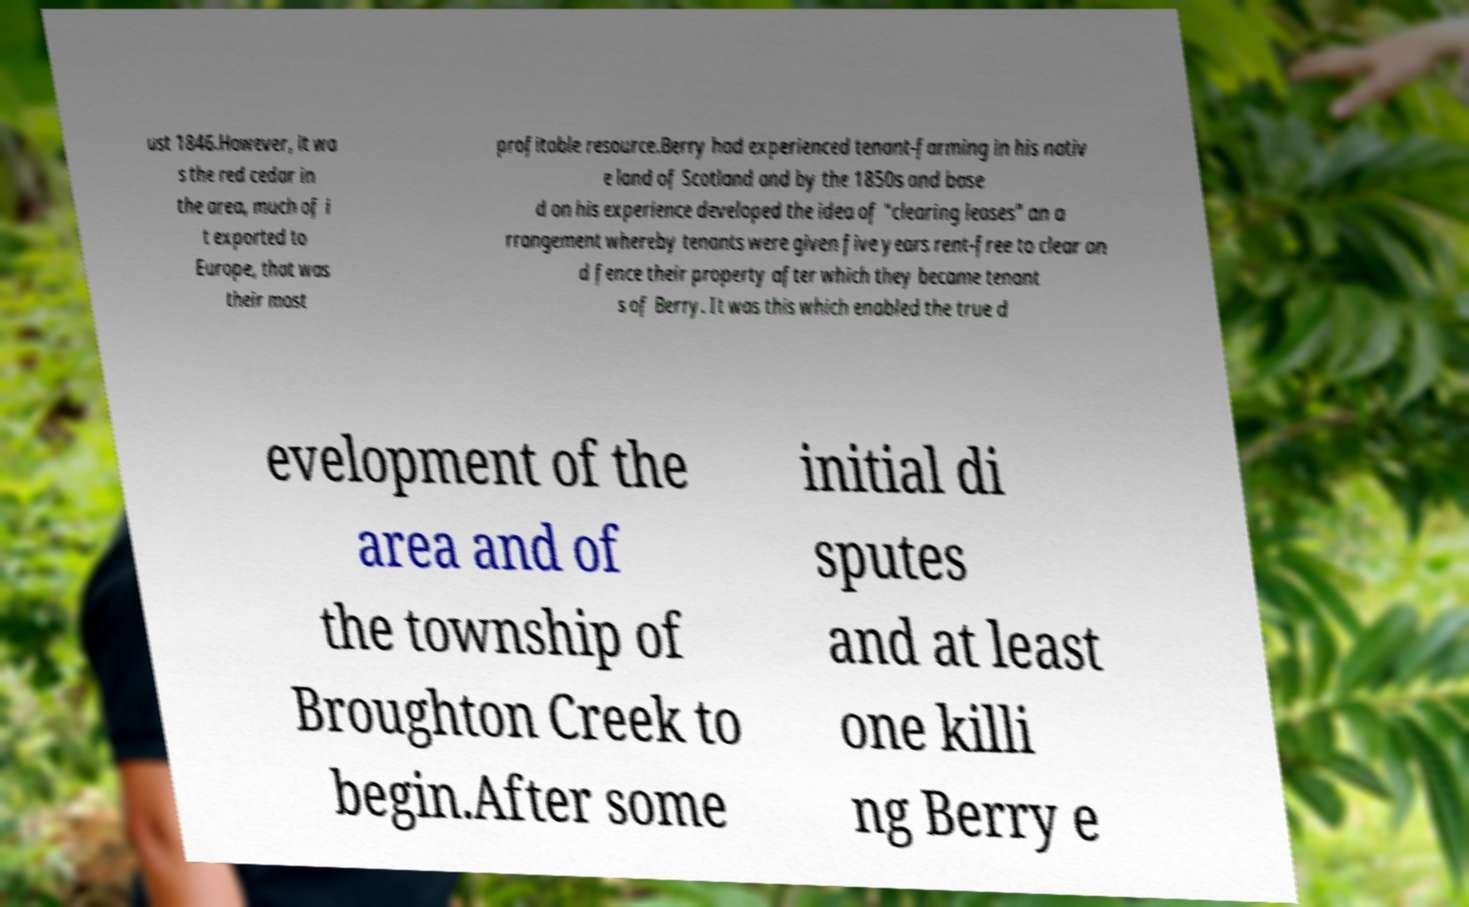What messages or text are displayed in this image? I need them in a readable, typed format. ust 1846.However, it wa s the red cedar in the area, much of i t exported to Europe, that was their most profitable resource.Berry had experienced tenant-farming in his nativ e land of Scotland and by the 1850s and base d on his experience developed the idea of "clearing leases" an a rrangement whereby tenants were given five years rent-free to clear an d fence their property after which they became tenant s of Berry. It was this which enabled the true d evelopment of the area and of the township of Broughton Creek to begin.After some initial di sputes and at least one killi ng Berry e 